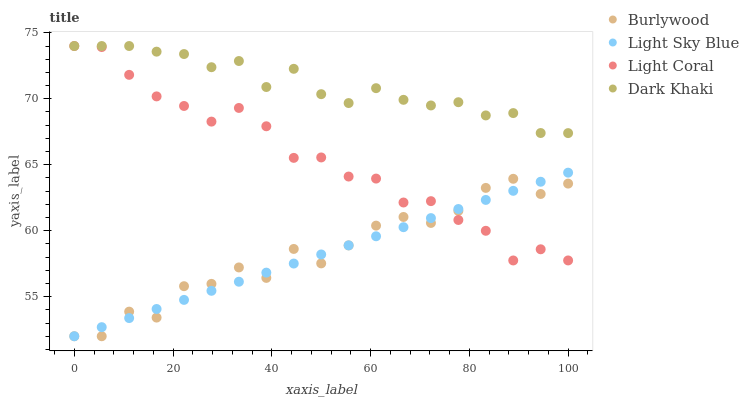Does Light Sky Blue have the minimum area under the curve?
Answer yes or no. Yes. Does Dark Khaki have the maximum area under the curve?
Answer yes or no. Yes. Does Light Coral have the minimum area under the curve?
Answer yes or no. No. Does Light Coral have the maximum area under the curve?
Answer yes or no. No. Is Light Sky Blue the smoothest?
Answer yes or no. Yes. Is Burlywood the roughest?
Answer yes or no. Yes. Is Light Coral the smoothest?
Answer yes or no. No. Is Light Coral the roughest?
Answer yes or no. No. Does Burlywood have the lowest value?
Answer yes or no. Yes. Does Light Coral have the lowest value?
Answer yes or no. No. Does Dark Khaki have the highest value?
Answer yes or no. Yes. Does Light Sky Blue have the highest value?
Answer yes or no. No. Is Light Sky Blue less than Dark Khaki?
Answer yes or no. Yes. Is Dark Khaki greater than Burlywood?
Answer yes or no. Yes. Does Light Coral intersect Light Sky Blue?
Answer yes or no. Yes. Is Light Coral less than Light Sky Blue?
Answer yes or no. No. Is Light Coral greater than Light Sky Blue?
Answer yes or no. No. Does Light Sky Blue intersect Dark Khaki?
Answer yes or no. No. 